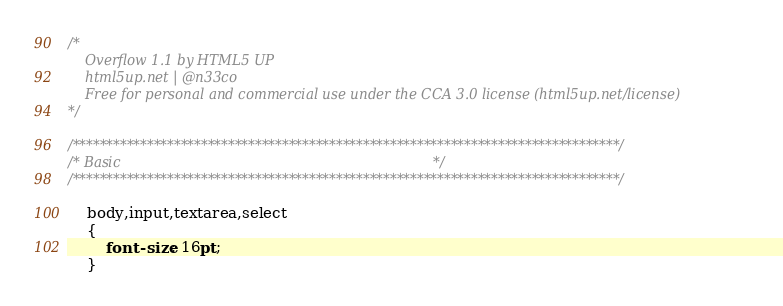<code> <loc_0><loc_0><loc_500><loc_500><_CSS_>/*
	Overflow 1.1 by HTML5 UP
	html5up.net | @n33co
	Free for personal and commercial use under the CCA 3.0 license (html5up.net/license)
*/

/*********************************************************************************/
/* Basic                                                                         */
/*********************************************************************************/

	body,input,textarea,select
	{
		font-size: 16pt;
	}</code> 